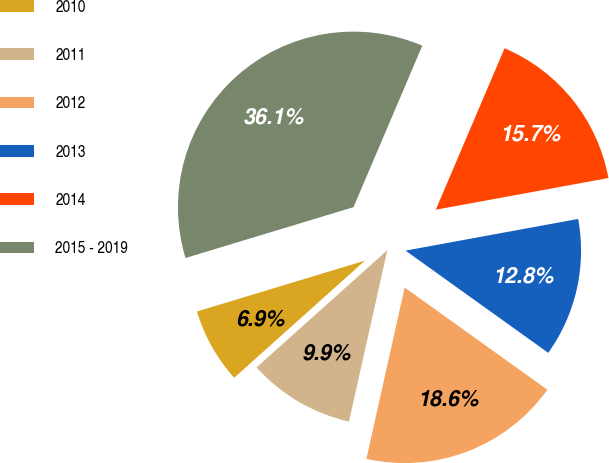<chart> <loc_0><loc_0><loc_500><loc_500><pie_chart><fcel>2010<fcel>2011<fcel>2012<fcel>2013<fcel>2014<fcel>2015 - 2019<nl><fcel>6.95%<fcel>9.87%<fcel>18.61%<fcel>12.78%<fcel>15.7%<fcel>36.09%<nl></chart> 